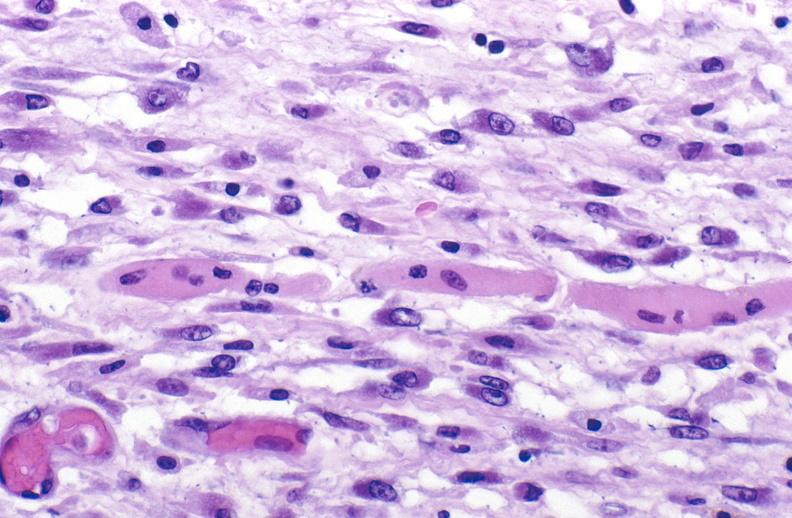does this image show tracheotomy site, granulation tissue?
Answer the question using a single word or phrase. Yes 